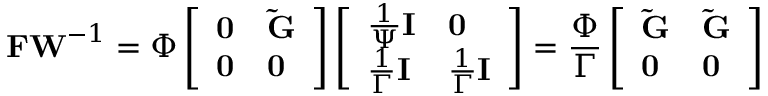<formula> <loc_0><loc_0><loc_500><loc_500>F W ^ { - 1 } = \Phi \left [ \begin{array} { l l } { 0 } & { \tilde { G } } \\ { 0 } & { 0 } \end{array} \right ] \left [ \begin{array} { l l } { \frac { 1 } { \Psi } I } & { 0 } \\ { \frac { 1 } { \Gamma } I } & { \frac { 1 } { \Gamma } I } \end{array} \right ] = \frac { \Phi } { \Gamma } \left [ \begin{array} { l l } { \tilde { G } } & { \tilde { G } } \\ { 0 } & { 0 } \end{array} \right ]</formula> 